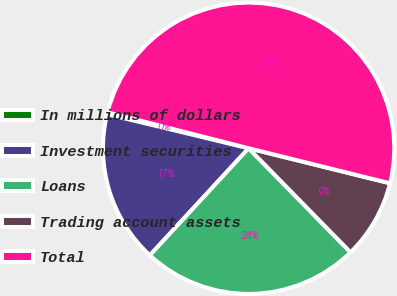Convert chart. <chart><loc_0><loc_0><loc_500><loc_500><pie_chart><fcel>In millions of dollars<fcel>Investment securities<fcel>Loans<fcel>Trading account assets<fcel>Total<nl><fcel>0.21%<fcel>16.9%<fcel>24.19%<fcel>8.8%<fcel>49.89%<nl></chart> 